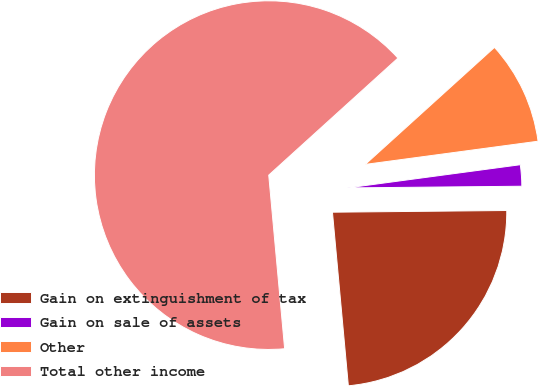Convert chart to OTSL. <chart><loc_0><loc_0><loc_500><loc_500><pie_chart><fcel>Gain on extinguishment of tax<fcel>Gain on sale of assets<fcel>Other<fcel>Total other income<nl><fcel>23.7%<fcel>1.97%<fcel>9.59%<fcel>64.74%<nl></chart> 